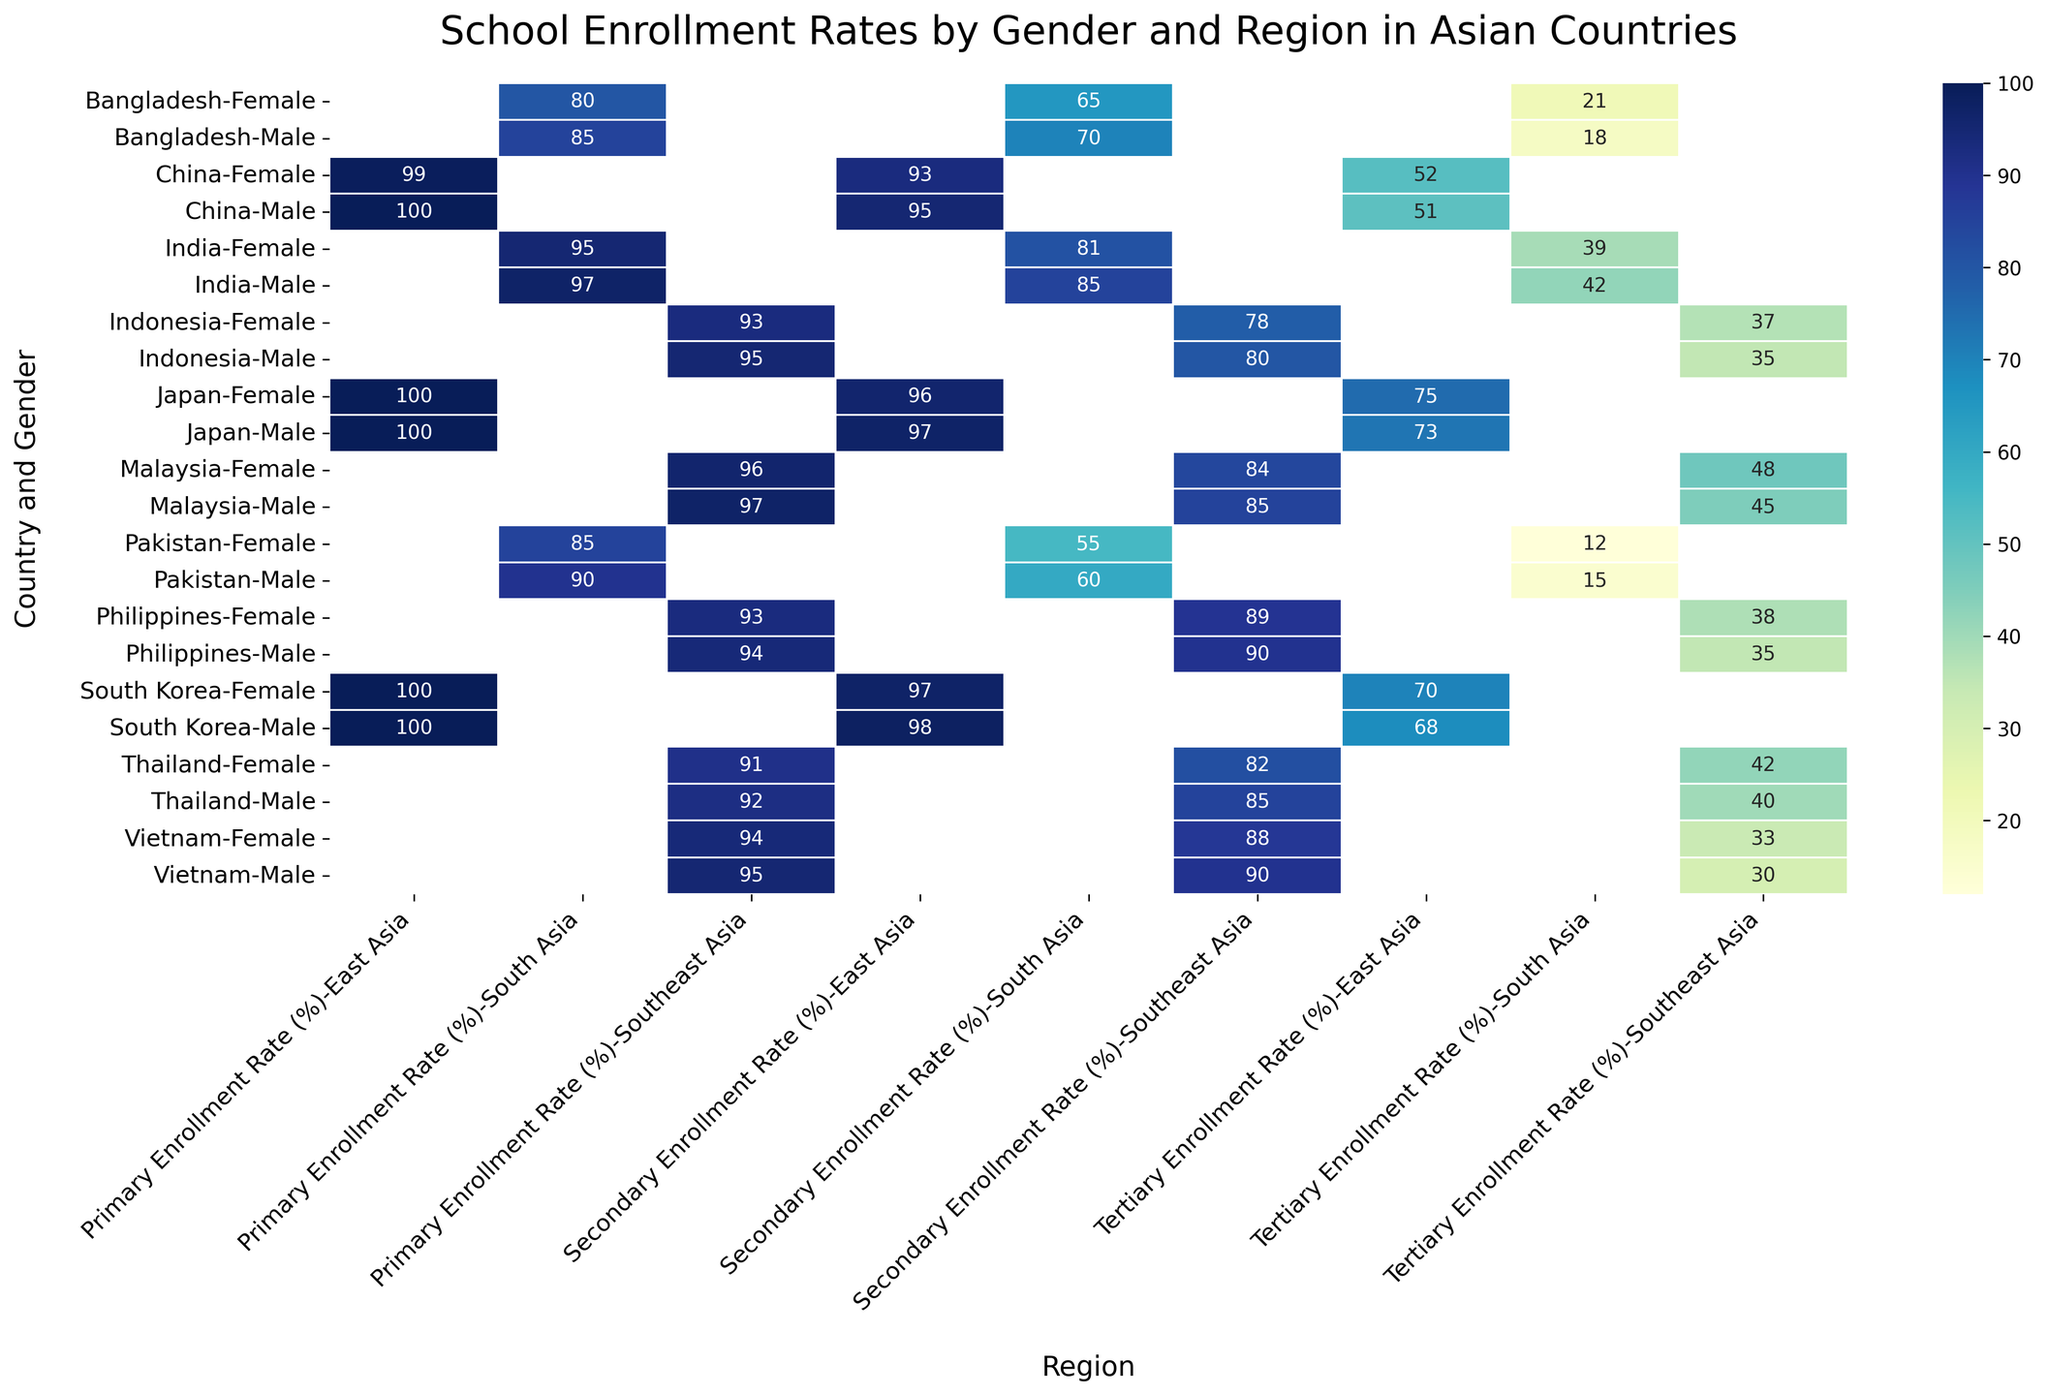What is the least tertiary enrollment rate for female students in the South Asia region? The heatmap shows different enrollment rates for females in South Asia. The countries in this region are India, Pakistan, and Bangladesh with female tertiary enrollment rates of 39%, 12%, and 21% respectively. The lowest value here is 12%, which corresponds to Pakistan.
Answer: 12% Which country has the smallest gap between male and female primary enrollment rates in Southeast Asia? We compare the primary enrollment rates for males and females in Southeast Asia: Indonesia (95% and 93%), Vietnam (95% and 94%), Thailand (92% and 91%), Philippines (94% and 93%), and Malaysia (97% and 96%). The smallest difference is 1%, found in Vietnam and Thailand.
Answer: Vietnam and Thailand What is the average secondary enrollment rate for male students in East Asia? The heatmap shows secondary enrollment rates for males in East Asia: China (95%), Japan (97%), and South Korea (98%). Summing these rates gives 95 + 97 + 98 = 290. The average is 290 / 3 = 96.67.
Answer: 96.67 Which region generally has higher tertiary enrollment rates for females compared to males? Reviewing the tertiary rates in each region: East Asia (higher in China, equal in Japan, higher in South Korea), South Asia (higher in Bangladesh), and Southeast Asia (higher in Indonesia and Malaysia, equal or higher in others). Southeast Asia shows a trend where more or equal countries have higher female tertiary enrollment rates compared to males.
Answer: Southeast Asia For India, what is the difference between male and female secondary enrollment rates? The heatmap shows that in India, the secondary enrollment rates are 85% for males and 81% for females. Subtracting these, the difference is 85 - 81 = 4.
Answer: 4 Which country in Southeast Asia has the highest primary enrollment rate for males? In the Southeast Asia region: Indonesia (95%), Vietnam (95%), Thailand (92%), Philippines (94%), and Malaysia (97%). The highest primary enrollment rate is found in Malaysia at 97%.
Answer: Malaysia Compare the secondary enrollment rates of males and females in Bangladesh. Which gender has the higher rate, and by how much? The secondary enrollment rates in Bangladesh are 70% for males and 65% for females. Males have a higher rate. The difference is 70 - 65 = 5.
Answer: Males, 5 What is the tertiary enrollment rate for females in East Asia, and how does it compare to males in the same region? Reviewing the tertiary rates in East Asia: China (52% female, 51% male), Japan (75% female, 73% male), and South Korea (70% female, 68% male). In all three countries, female rates are higher than male rates. The differences are 1%, 2%, and 2% respectively.
Answer: 70%, Higher How does Japan's male tertiary enrollment rate compare to South Korea's male tertiary enrollment rate? The heatmap indicates that Japan's male tertiary enrollment rate is 73% and South Korea's male tertiary enrollment rate is 68%. Comparing these, Japan's rate is higher.
Answer: Higher What is the overall highest primary enrollment rate, and in which country and gender does it occur? By scanning the heatmap, the primary enrollment rate for both males and females in several countries reaches 100%. These countries include China, Japan, and South Korea for both genders. Thus, the highest rate (100%) occurs in these countries for both genders.
Answer: 100%, China, Japan, and South Korea for both genders 